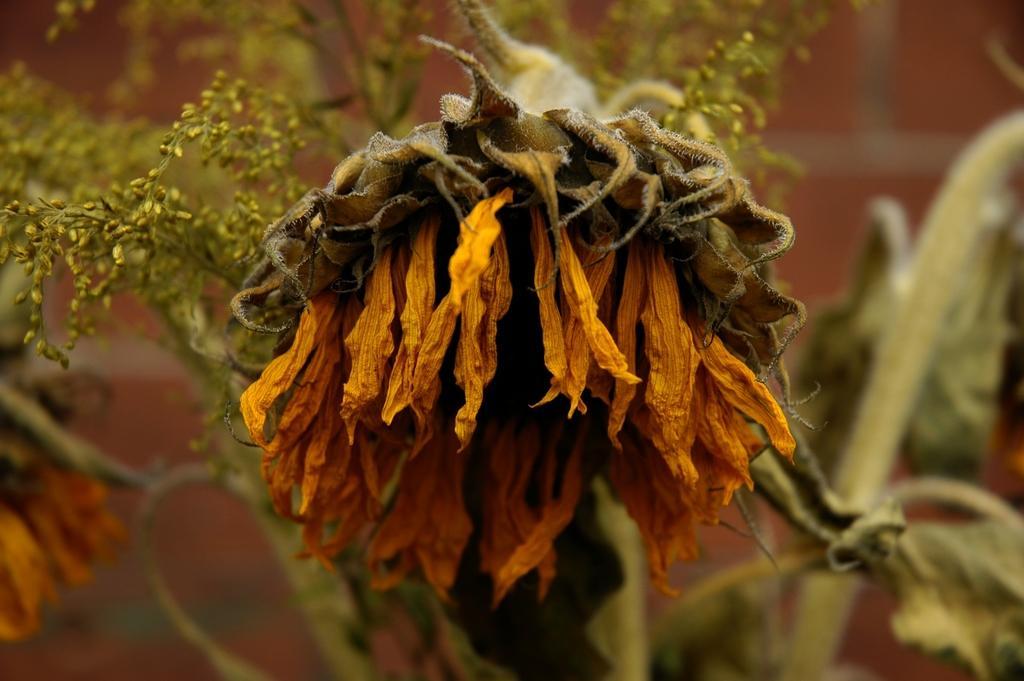Can you describe this image briefly? This image is taken outdoors. In this image there is a plant and in the middle of the image there is a dried sunflower. 